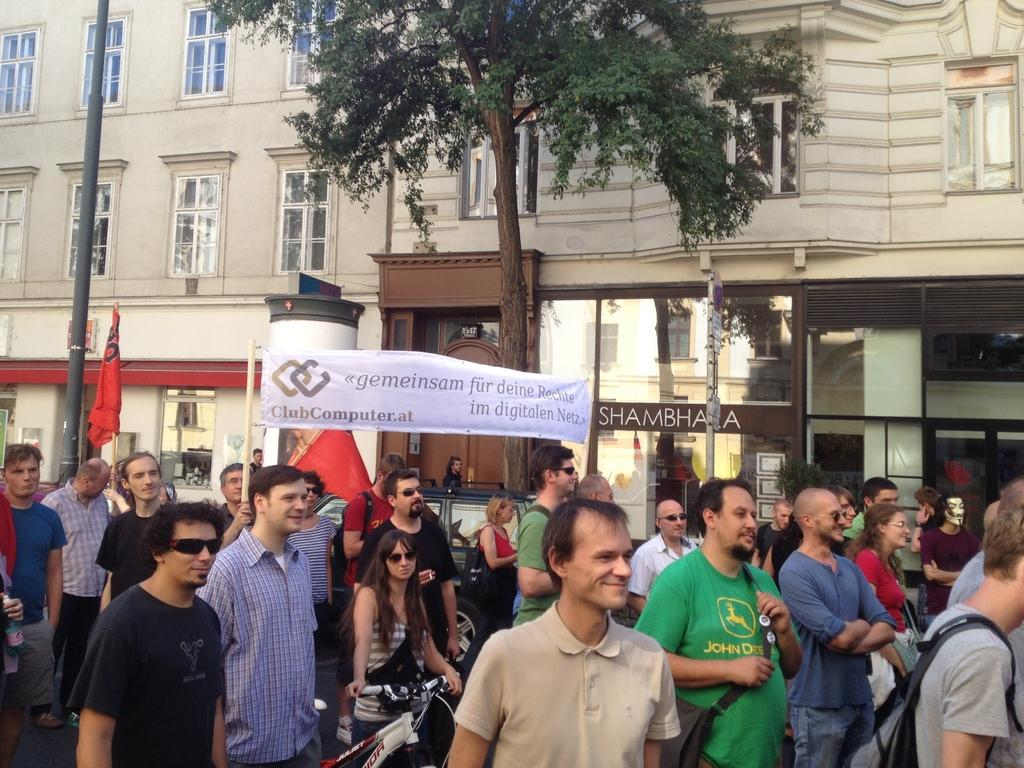How many people are present in the image? There are many people in the image. What are some people holding in the image? Some people are holding flags and banners in the image. What can be seen in the background of the image? There are buildings, a tree, and a pole in the background of the image. What type of crow is sitting on the guitar in the image? There is no crow or guitar present in the image. What company is sponsoring the event in the image? The provided facts do not mention any company or event, so it cannot be determined from the image. 